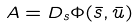Convert formula to latex. <formula><loc_0><loc_0><loc_500><loc_500>A = { D } _ { s } { \Phi } ( \bar { s } , \bar { u } )</formula> 